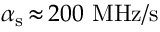Convert formula to latex. <formula><loc_0><loc_0><loc_500><loc_500>\alpha _ { s } \, { \approx } \, 2 0 0 M H z / s</formula> 